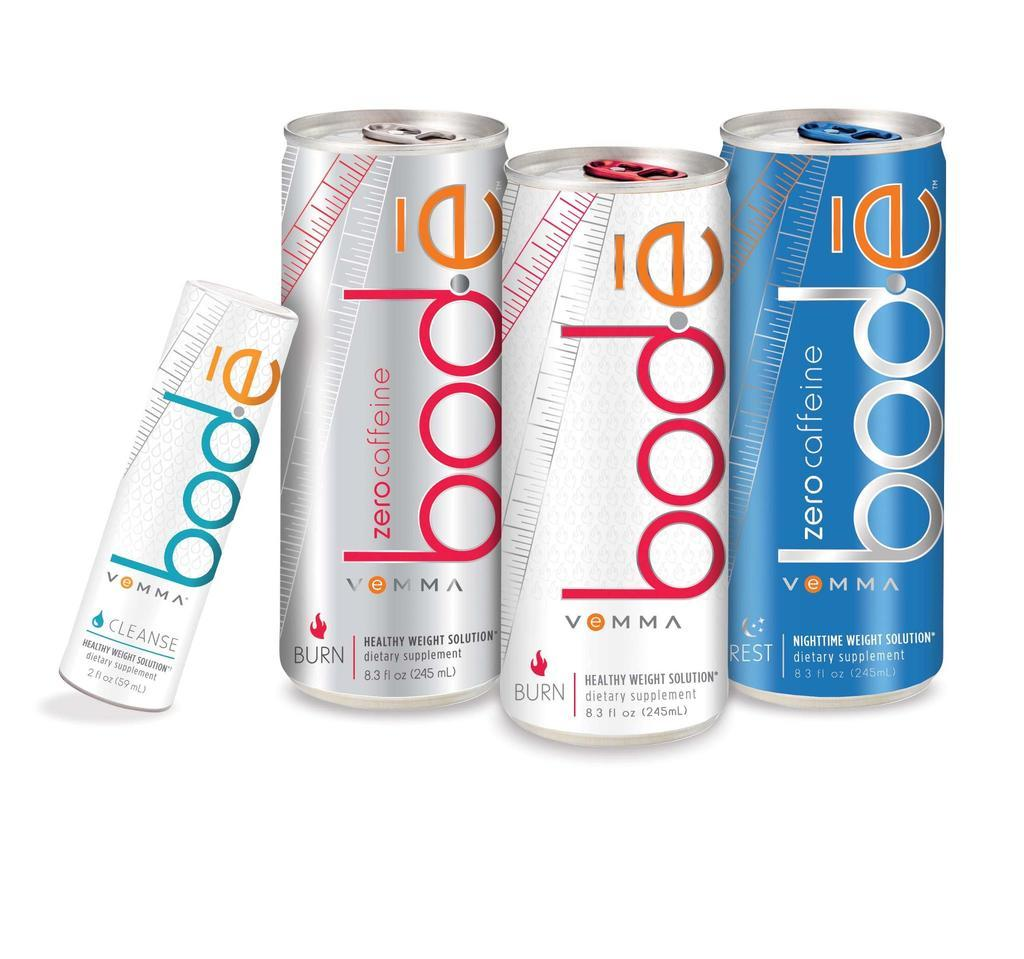Provide a one-sentence caption for the provided image. A image of four cans of Bode Zero Caffeine beverages. 